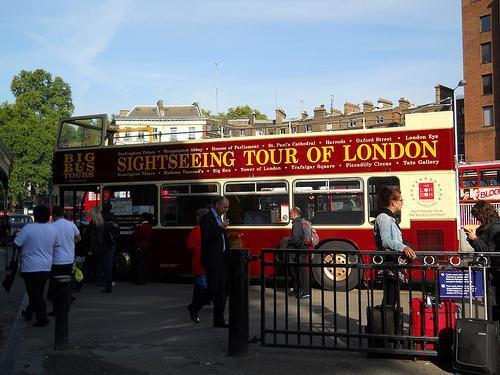How many people are standing by the fence?
Give a very brief answer. 2. 